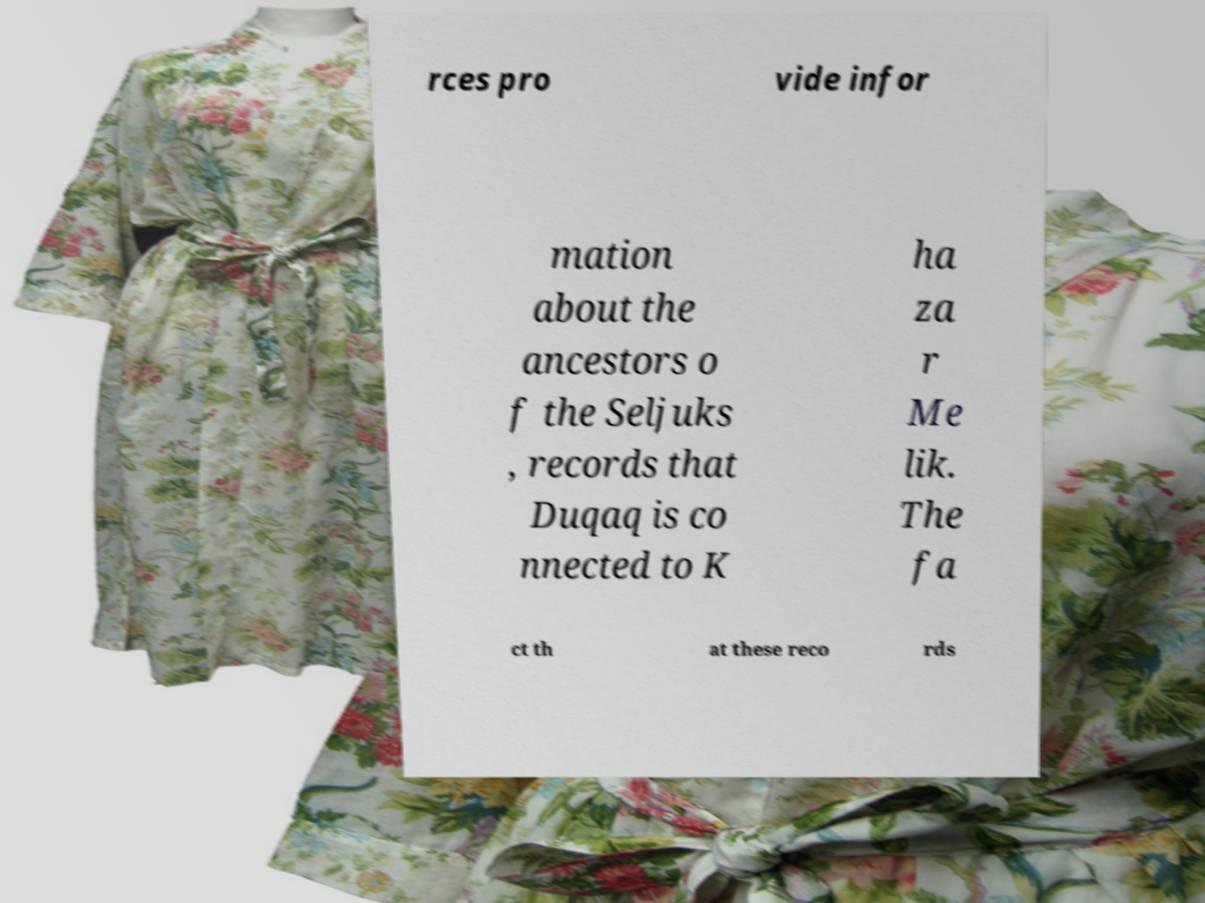There's text embedded in this image that I need extracted. Can you transcribe it verbatim? rces pro vide infor mation about the ancestors o f the Seljuks , records that Duqaq is co nnected to K ha za r Me lik. The fa ct th at these reco rds 